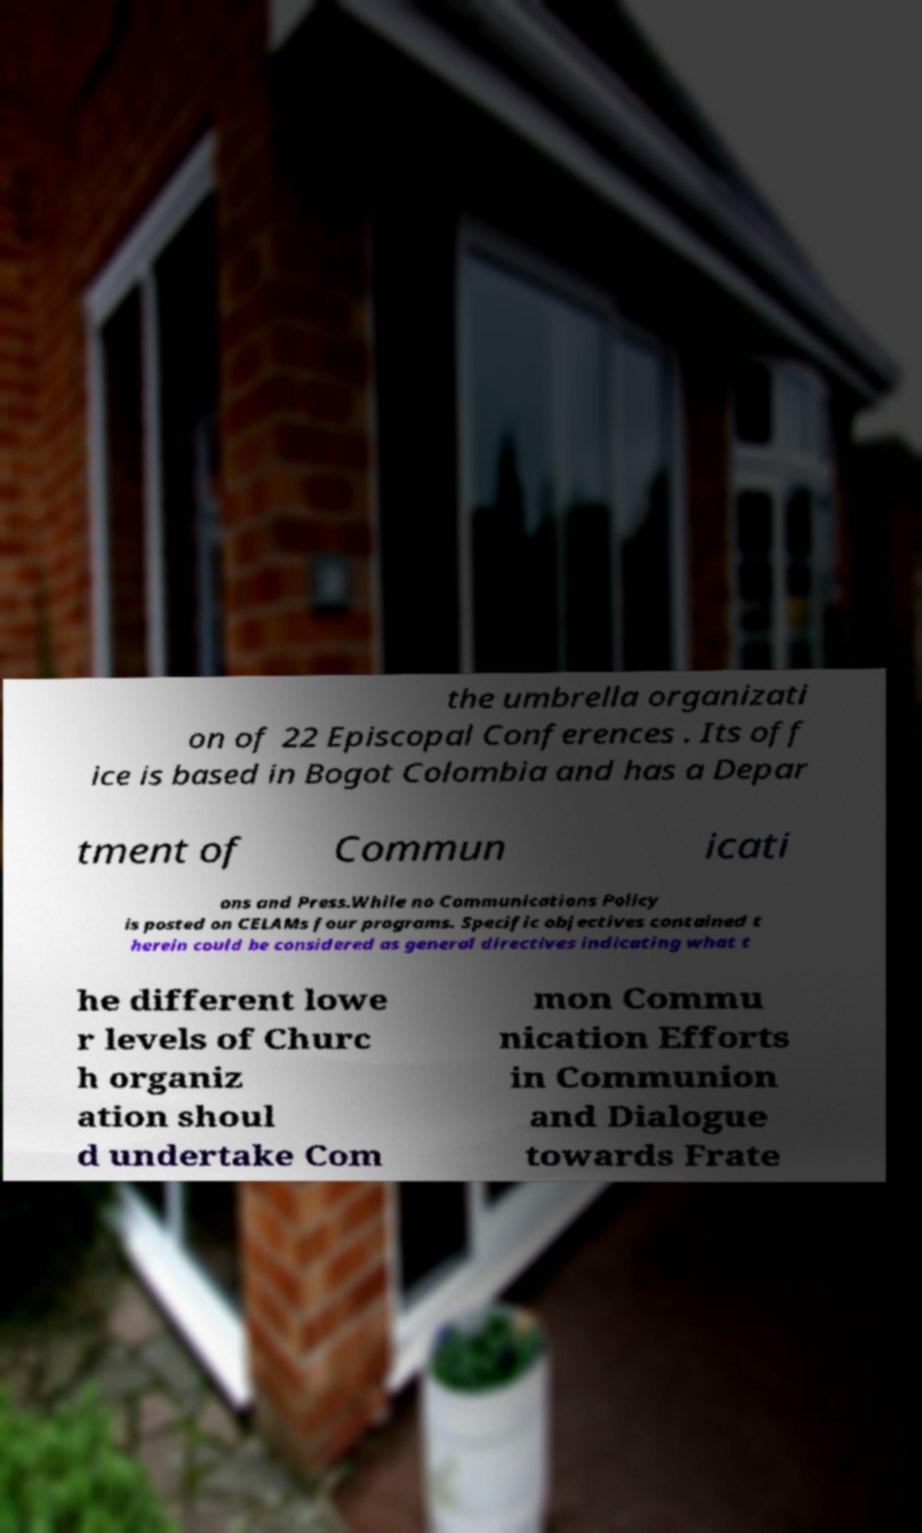Please identify and transcribe the text found in this image. the umbrella organizati on of 22 Episcopal Conferences . Its off ice is based in Bogot Colombia and has a Depar tment of Commun icati ons and Press.While no Communications Policy is posted on CELAMs four programs. Specific objectives contained t herein could be considered as general directives indicating what t he different lowe r levels of Churc h organiz ation shoul d undertake Com mon Commu nication Efforts in Communion and Dialogue towards Frate 